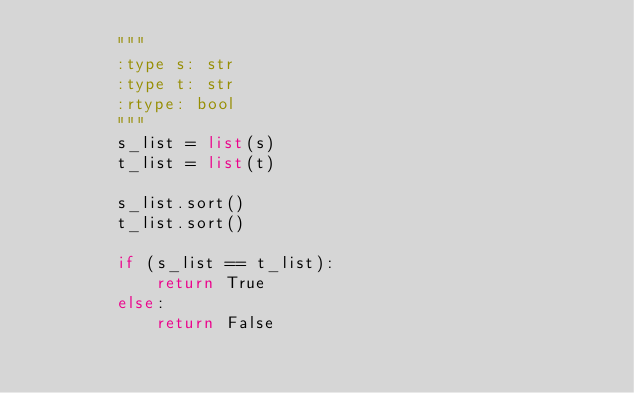Convert code to text. <code><loc_0><loc_0><loc_500><loc_500><_Python_>        """
        :type s: str
        :type t: str
        :rtype: bool
        """
        s_list = list(s)
        t_list = list(t)
        
        s_list.sort()
        t_list.sort()
        
        if (s_list == t_list):
            return True
        else:
            return False
</code> 